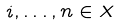<formula> <loc_0><loc_0><loc_500><loc_500>i , \dots , n \in X</formula> 